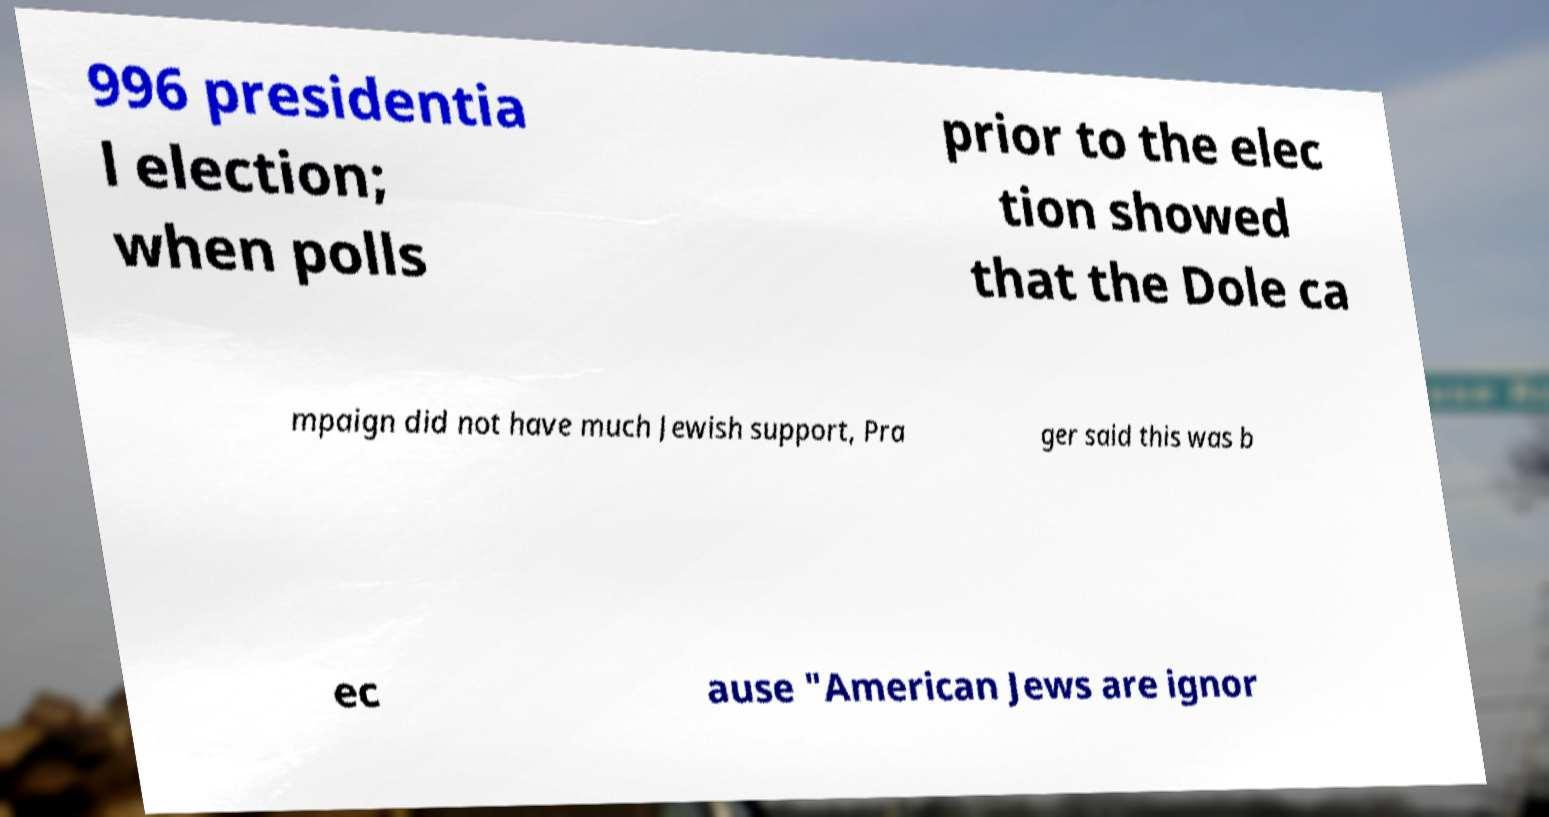Could you assist in decoding the text presented in this image and type it out clearly? 996 presidentia l election; when polls prior to the elec tion showed that the Dole ca mpaign did not have much Jewish support, Pra ger said this was b ec ause "American Jews are ignor 